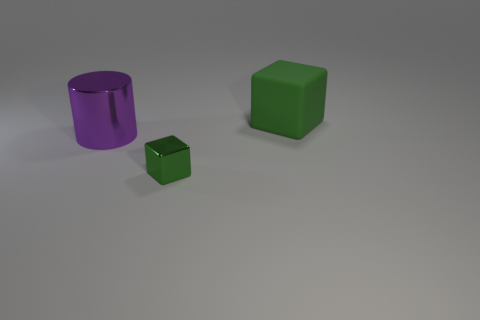The thing that is right of the large purple metallic thing and in front of the large green matte cube has what shape?
Your answer should be very brief. Cube. The metal thing that is the same shape as the large green matte object is what color?
Offer a terse response. Green. What number of things are either green cubes that are in front of the large green cube or shiny objects that are to the left of the tiny thing?
Ensure brevity in your answer.  2. What shape is the big matte object?
Offer a very short reply. Cube. There is a big object that is the same color as the metallic block; what shape is it?
Your answer should be compact. Cube. How many big blocks have the same material as the big purple cylinder?
Provide a short and direct response. 0. The big cylinder is what color?
Provide a succinct answer. Purple. There is a rubber thing that is the same size as the purple metal object; what color is it?
Make the answer very short. Green. Are there any blocks of the same color as the large cylinder?
Provide a short and direct response. No. Is the shape of the green object in front of the purple thing the same as the large thing that is to the left of the big green object?
Keep it short and to the point. No. 